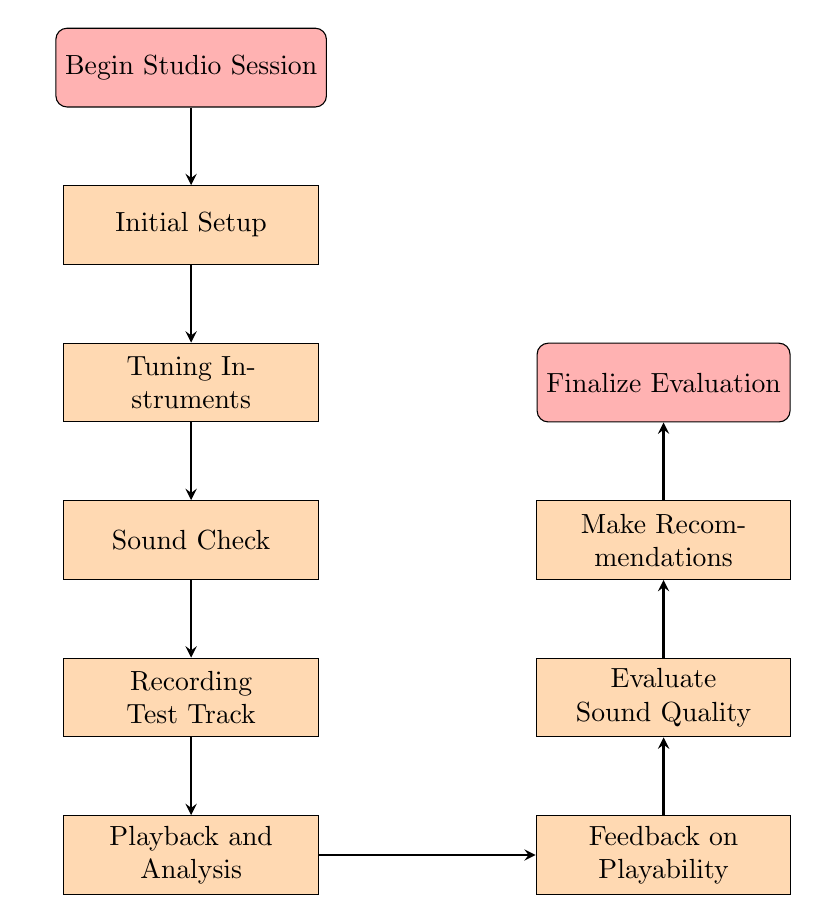What is the first step in the diagram? The first step is labeled "Begin Studio Session", indicating the initiation of the process. This is the node from which the flowchart starts.
Answer: Begin Studio Session How many nodes are present in the diagram? The diagram includes a total of eight nodes, with the additional start and end nodes making it ten in total, but considering only the main steps there are eight.
Answer: Eight What is the last step before finalizing the evaluation? The last step before finalizing the evaluation is "Make Recommendations", which suggests it is the concluding action taken in the process before reaching the end node.
Answer: Make Recommendations Which step involves reviewing the test track recordings? The step that involves reviewing the test track recordings is denoted as "Playback and Analysis", where the recordings are assessed for further actions.
Answer: Playback and Analysis In which step is feedback on playability provided? Feedback on playability is provided in the "Feedback on Playability" step, where the player assesses the comfort and ease of playing each guitar.
Answer: Feedback on Playability What follows after Tuning Instruments? Following "Tuning Instruments", the next step in the process is "Sound Check", which indicates the sequence of tasks during the studio session.
Answer: Sound Check How many steps are there between Initial Setup and Make Recommendations? There are five steps between "Initial Setup" and "Make Recommendations": Tuning Instruments, Sound Check, Recording Test Track, Playback and Analysis, and Feedback on Playability.
Answer: Five What is the purpose of the Evaluate Sound Quality step? The purpose of the "Evaluate Sound Quality" step is to assess the sound quality of each guitar based on specific criteria such as tone, sustain, and clarity.
Answer: To evaluate sound quality What type of node is used to represent the start and end of the flowchart? The type of node used to represent the start and end of the flowchart is called a "startstop" node, which is specifically designed for indicating the beginning and the conclusion of the process.
Answer: Startstop 